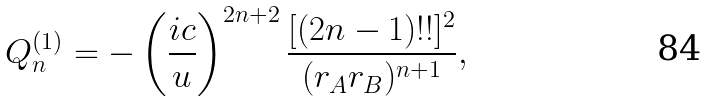Convert formula to latex. <formula><loc_0><loc_0><loc_500><loc_500>Q _ { n } ^ { ( 1 ) } = - \left ( \frac { i c } { u } \right ) ^ { 2 n + 2 } \frac { [ ( 2 n - 1 ) ! ! ] ^ { 2 } } { ( r _ { A } r _ { B } ) ^ { n + 1 } } ,</formula> 